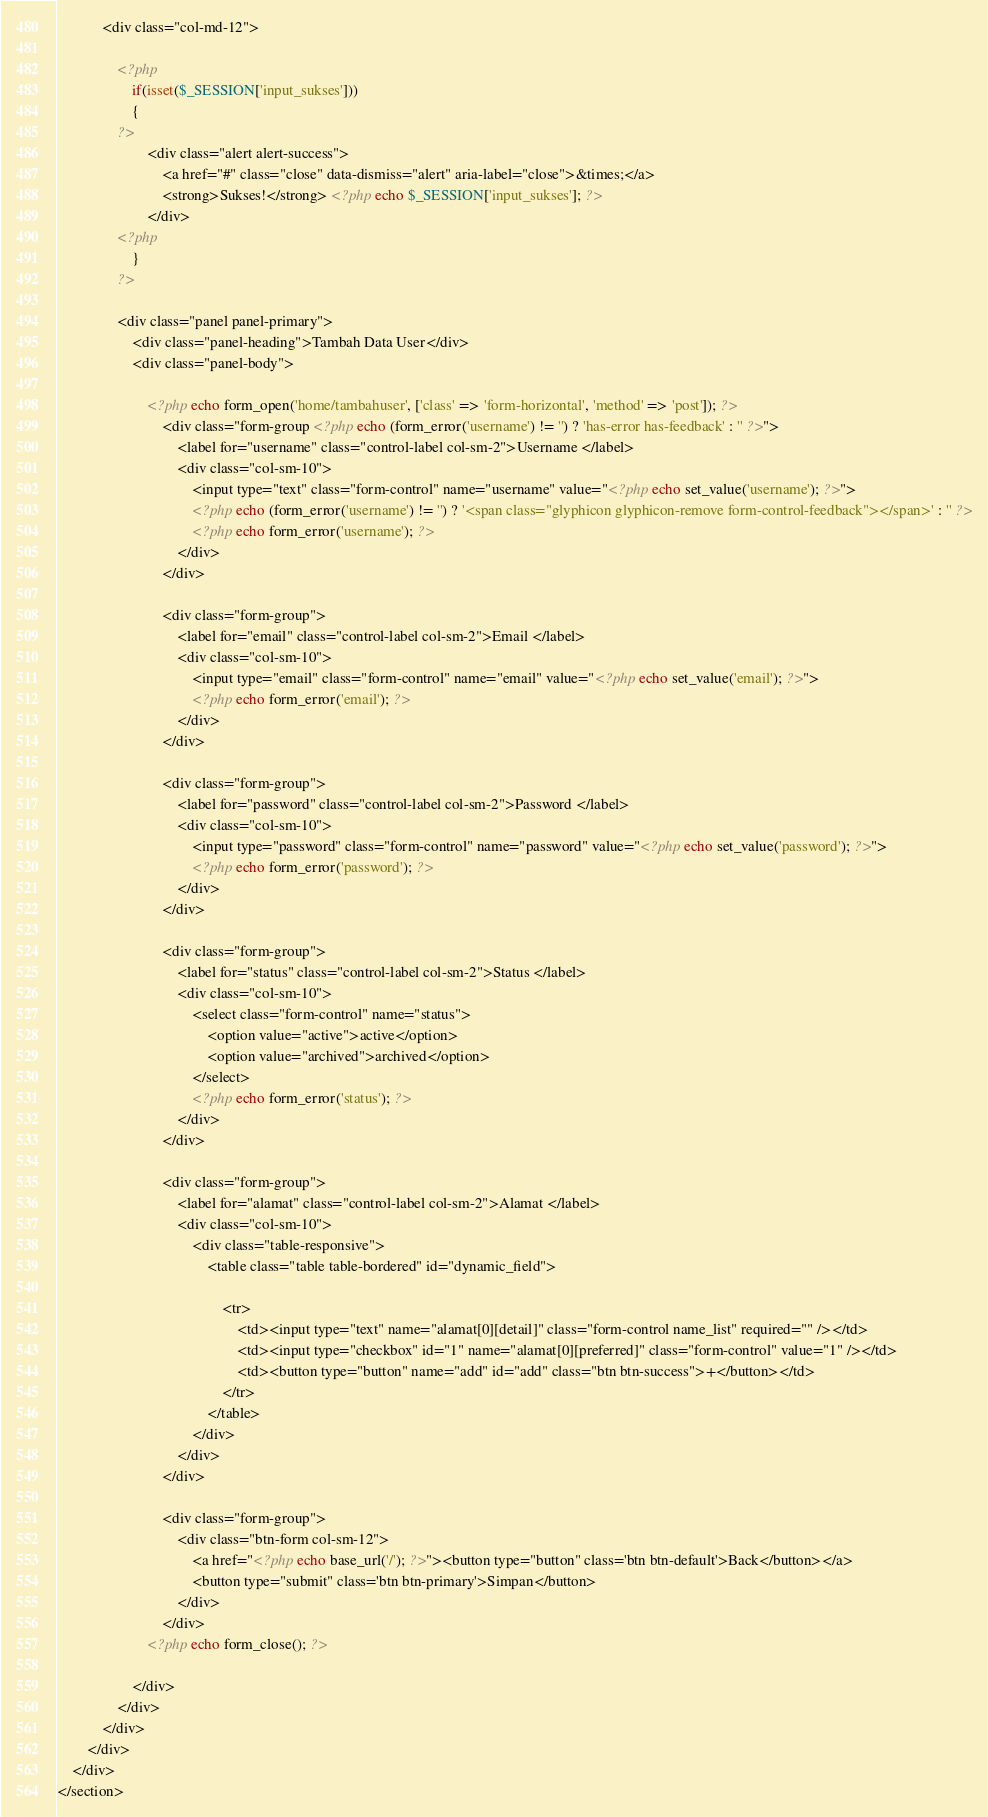Convert code to text. <code><loc_0><loc_0><loc_500><loc_500><_PHP_>			<div class="col-md-12">
				
				<?php
					if(isset($_SESSION['input_sukses']))
					{
				?>
						<div class="alert alert-success">
							<a href="#" class="close" data-dismiss="alert" aria-label="close">&times;</a>
						  	<strong>Sukses!</strong> <?php echo $_SESSION['input_sukses']; ?>
						</div>
				<?php
					}
				?>

				<div class="panel panel-primary">
					<div class="panel-heading">Tambah Data User</div>
					<div class="panel-body">
						
						<?php echo form_open('home/tambahuser', ['class' => 'form-horizontal', 'method' => 'post']); ?>
							<div class="form-group <?php echo (form_error('username') != '') ? 'has-error has-feedback' : '' ?>">
								<label for="username" class="control-label col-sm-2">Username </label>
								<div class="col-sm-10">
									<input type="text" class="form-control" name="username" value="<?php echo set_value('username'); ?>">
									<?php echo (form_error('username') != '') ? '<span class="glyphicon glyphicon-remove form-control-feedback"></span>' : '' ?>
									<?php echo form_error('username'); ?>
								</div>
							</div>

							<div class="form-group">
								<label for="email" class="control-label col-sm-2">Email </label>
								<div class="col-sm-10">
									<input type="email" class="form-control" name="email" value="<?php echo set_value('email'); ?>">
									<?php echo form_error('email'); ?>
								</div>
							</div>

							<div class="form-group">
								<label for="password" class="control-label col-sm-2">Password </label>
								<div class="col-sm-10">
									<input type="password" class="form-control" name="password" value="<?php echo set_value('password'); ?>">
									<?php echo form_error('password'); ?>
								</div>
							</div>

							<div class="form-group">
								<label for="status" class="control-label col-sm-2">Status </label>
								<div class="col-sm-10">
									<select class="form-control" name="status">
										<option value="active">active</option>
										<option value="archived">archived</option>
									</select>
									<?php echo form_error('status'); ?>
								</div>
							</div>

							<div class="form-group">
								<label for="alamat" class="control-label col-sm-2">Alamat </label>
								<div class="col-sm-10">
							        <div class="table-responsive">  
						                <table class="table table-bordered" id="dynamic_field">

						                    <tr>  
						                        <td><input type="text" name="alamat[0][detail]" class="form-control name_list" required="" /></td>
						                        <td><input type="checkbox" id="1" name="alamat[0][preferred]" class="form-control" value="1" /></td>  
						                        <td><button type="button" name="add" id="add" class="btn btn-success">+</button></td>  
						                    </tr>  
						                </table> 
						            </div>
								</div>
							</div>

							<div class="form-group">
								<div class="btn-form col-sm-12">
									<a href="<?php echo base_url('/'); ?>"><button type="button" class='btn btn-default'>Back</button></a>
									<button type="submit" class='btn btn-primary'>Simpan</button>
								</div>
							</div>
						<?php echo form_close(); ?>

					</div>
				</div>
			</div>
		</div>
	</div>
</section></code> 